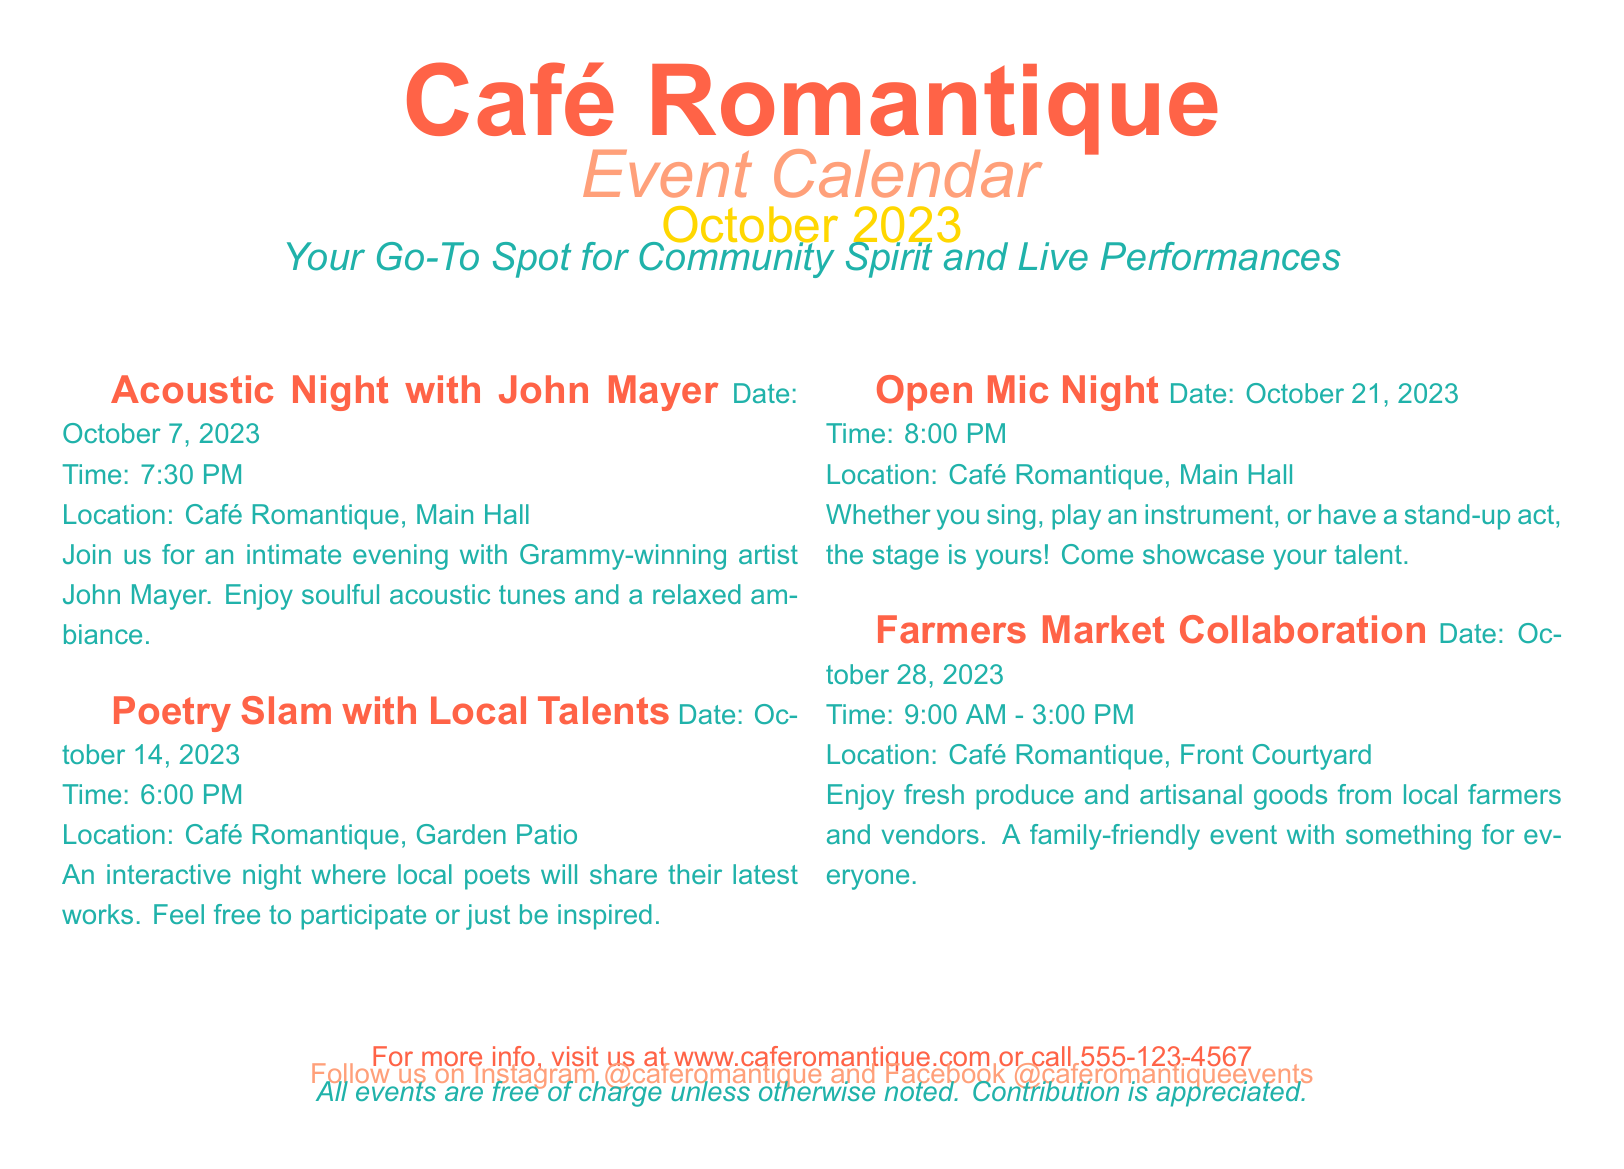What is the name of the first event? The first event listed in the document is "Acoustic Night with John Mayer."
Answer: Acoustic Night with John Mayer When is the Poetry Slam scheduled? The document states that the Poetry Slam is scheduled for October 14, 2023.
Answer: October 14, 2023 What time does the Open Mic Night start? According to the document, Open Mic Night starts at 8:00 PM.
Answer: 8:00 PM Where is the Farmers Market Collaboration held? The document indicates that the Farmers Market Collaboration is held at the Front Courtyard of Café Romantique.
Answer: Front Courtyard How many events are listed in total? The document lists four events in total.
Answer: Four What type of event is scheduled for October 28, 2023? The event scheduled for October 28, 2023, is a "Farmers Market Collaboration."
Answer: Farmers Market Collaboration Who is performing at the Acoustic Night? The document states that Grammy-winning artist John Mayer is performing.
Answer: John Mayer Which area of the café hosts the Open Mic Night? The Open Mic Night is hosted in the Main Hall of Café Romantique.
Answer: Main Hall Are the events at Café Romantique free? The document notes that all events are free of charge unless otherwise noted.
Answer: Free 